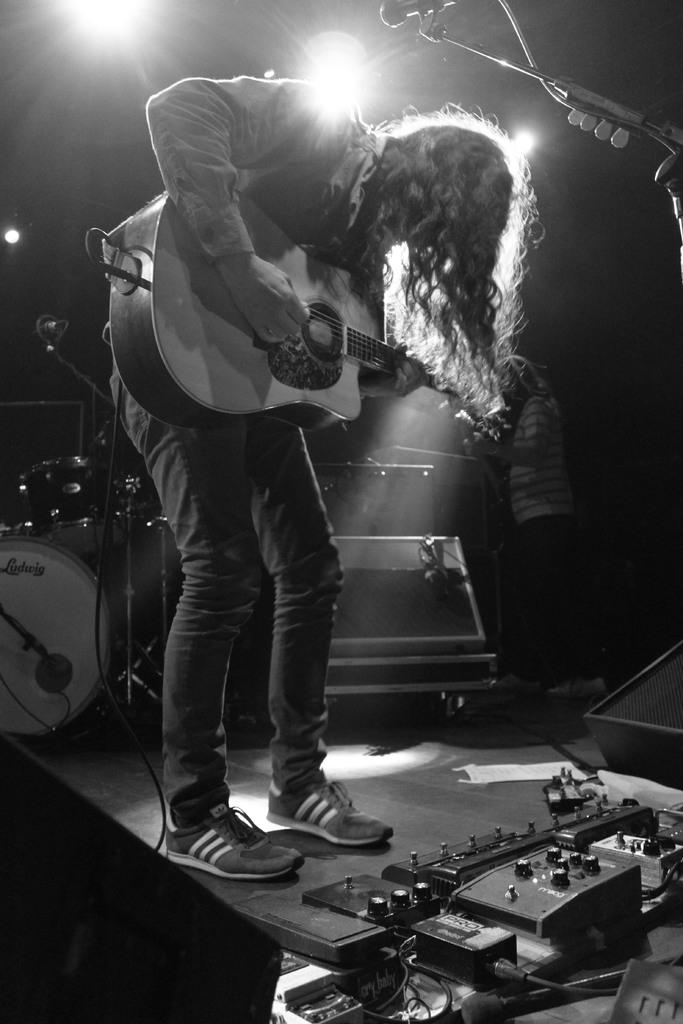What is the person in the image holding? The person is holding a guitar. What else can be seen in the image related to music? There are musical instruments visible in the image, and there is a microphone with a stand. How many people are in the image? There are two people in the image. What is present at the top of the image? Focusing lights are present at the top of the image. What type of wrench is being used to tune the guitar in the image? There is no wrench present in the image, and the guitar does not appear to be in the process of being tuned. 